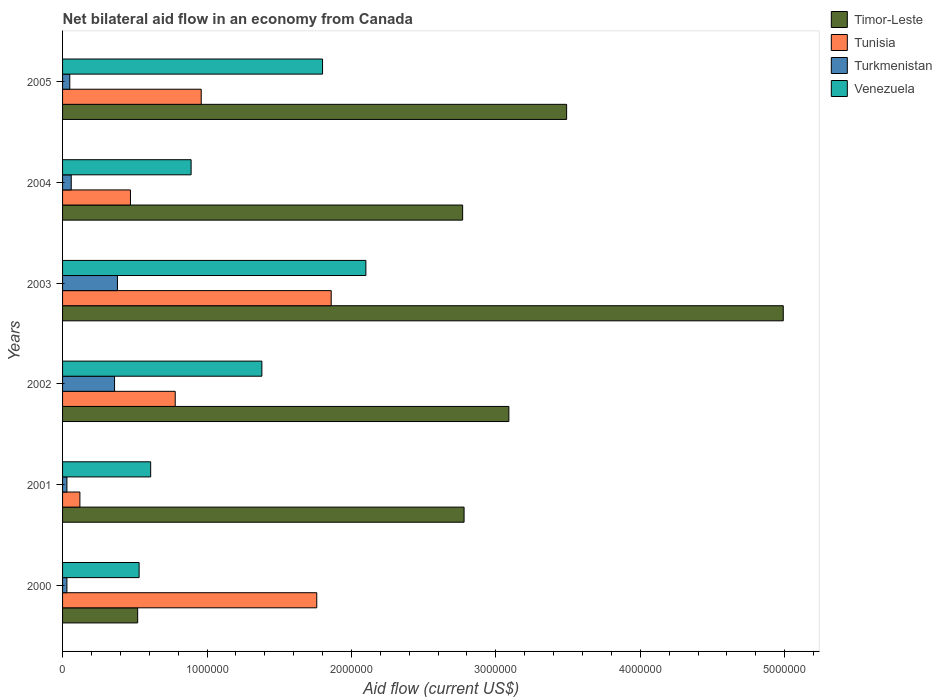How many groups of bars are there?
Give a very brief answer. 6. Are the number of bars per tick equal to the number of legend labels?
Your response must be concise. Yes. How many bars are there on the 5th tick from the top?
Offer a very short reply. 4. What is the label of the 4th group of bars from the top?
Offer a terse response. 2002. In how many cases, is the number of bars for a given year not equal to the number of legend labels?
Offer a very short reply. 0. What is the net bilateral aid flow in Venezuela in 2002?
Provide a succinct answer. 1.38e+06. In which year was the net bilateral aid flow in Tunisia minimum?
Make the answer very short. 2001. What is the total net bilateral aid flow in Venezuela in the graph?
Ensure brevity in your answer.  7.31e+06. What is the difference between the net bilateral aid flow in Venezuela in 2004 and that in 2005?
Your answer should be very brief. -9.10e+05. What is the difference between the net bilateral aid flow in Tunisia in 2000 and the net bilateral aid flow in Timor-Leste in 2001?
Your answer should be very brief. -1.02e+06. What is the average net bilateral aid flow in Timor-Leste per year?
Provide a succinct answer. 2.94e+06. In the year 2003, what is the difference between the net bilateral aid flow in Tunisia and net bilateral aid flow in Venezuela?
Make the answer very short. -2.40e+05. In how many years, is the net bilateral aid flow in Venezuela greater than 2000000 US$?
Provide a succinct answer. 1. What is the ratio of the net bilateral aid flow in Venezuela in 2001 to that in 2002?
Keep it short and to the point. 0.44. What is the difference between the highest and the second highest net bilateral aid flow in Turkmenistan?
Keep it short and to the point. 2.00e+04. What is the difference between the highest and the lowest net bilateral aid flow in Timor-Leste?
Offer a terse response. 4.47e+06. Is the sum of the net bilateral aid flow in Timor-Leste in 2002 and 2004 greater than the maximum net bilateral aid flow in Venezuela across all years?
Provide a succinct answer. Yes. What does the 3rd bar from the top in 2000 represents?
Ensure brevity in your answer.  Tunisia. What does the 1st bar from the bottom in 2002 represents?
Your answer should be very brief. Timor-Leste. Are all the bars in the graph horizontal?
Your response must be concise. Yes. How many years are there in the graph?
Provide a short and direct response. 6. Are the values on the major ticks of X-axis written in scientific E-notation?
Provide a short and direct response. No. Does the graph contain grids?
Offer a terse response. No. How many legend labels are there?
Ensure brevity in your answer.  4. How are the legend labels stacked?
Your response must be concise. Vertical. What is the title of the graph?
Provide a short and direct response. Net bilateral aid flow in an economy from Canada. Does "Middle East & North Africa (all income levels)" appear as one of the legend labels in the graph?
Ensure brevity in your answer.  No. What is the label or title of the X-axis?
Offer a very short reply. Aid flow (current US$). What is the Aid flow (current US$) of Timor-Leste in 2000?
Offer a very short reply. 5.20e+05. What is the Aid flow (current US$) in Tunisia in 2000?
Your answer should be very brief. 1.76e+06. What is the Aid flow (current US$) in Turkmenistan in 2000?
Keep it short and to the point. 3.00e+04. What is the Aid flow (current US$) of Venezuela in 2000?
Your response must be concise. 5.30e+05. What is the Aid flow (current US$) in Timor-Leste in 2001?
Offer a very short reply. 2.78e+06. What is the Aid flow (current US$) of Tunisia in 2001?
Keep it short and to the point. 1.20e+05. What is the Aid flow (current US$) of Timor-Leste in 2002?
Your answer should be compact. 3.09e+06. What is the Aid flow (current US$) of Tunisia in 2002?
Offer a terse response. 7.80e+05. What is the Aid flow (current US$) of Venezuela in 2002?
Make the answer very short. 1.38e+06. What is the Aid flow (current US$) of Timor-Leste in 2003?
Provide a succinct answer. 4.99e+06. What is the Aid flow (current US$) in Tunisia in 2003?
Provide a succinct answer. 1.86e+06. What is the Aid flow (current US$) of Turkmenistan in 2003?
Your answer should be very brief. 3.80e+05. What is the Aid flow (current US$) in Venezuela in 2003?
Offer a very short reply. 2.10e+06. What is the Aid flow (current US$) of Timor-Leste in 2004?
Offer a terse response. 2.77e+06. What is the Aid flow (current US$) in Venezuela in 2004?
Give a very brief answer. 8.90e+05. What is the Aid flow (current US$) of Timor-Leste in 2005?
Offer a very short reply. 3.49e+06. What is the Aid flow (current US$) in Tunisia in 2005?
Make the answer very short. 9.60e+05. What is the Aid flow (current US$) of Venezuela in 2005?
Your response must be concise. 1.80e+06. Across all years, what is the maximum Aid flow (current US$) in Timor-Leste?
Ensure brevity in your answer.  4.99e+06. Across all years, what is the maximum Aid flow (current US$) of Tunisia?
Provide a short and direct response. 1.86e+06. Across all years, what is the maximum Aid flow (current US$) of Turkmenistan?
Your response must be concise. 3.80e+05. Across all years, what is the maximum Aid flow (current US$) of Venezuela?
Your answer should be compact. 2.10e+06. Across all years, what is the minimum Aid flow (current US$) of Timor-Leste?
Your answer should be compact. 5.20e+05. Across all years, what is the minimum Aid flow (current US$) of Tunisia?
Make the answer very short. 1.20e+05. Across all years, what is the minimum Aid flow (current US$) in Turkmenistan?
Keep it short and to the point. 3.00e+04. Across all years, what is the minimum Aid flow (current US$) in Venezuela?
Your answer should be compact. 5.30e+05. What is the total Aid flow (current US$) of Timor-Leste in the graph?
Provide a succinct answer. 1.76e+07. What is the total Aid flow (current US$) of Tunisia in the graph?
Offer a very short reply. 5.95e+06. What is the total Aid flow (current US$) in Turkmenistan in the graph?
Provide a short and direct response. 9.10e+05. What is the total Aid flow (current US$) of Venezuela in the graph?
Keep it short and to the point. 7.31e+06. What is the difference between the Aid flow (current US$) in Timor-Leste in 2000 and that in 2001?
Provide a short and direct response. -2.26e+06. What is the difference between the Aid flow (current US$) in Tunisia in 2000 and that in 2001?
Provide a succinct answer. 1.64e+06. What is the difference between the Aid flow (current US$) of Turkmenistan in 2000 and that in 2001?
Keep it short and to the point. 0. What is the difference between the Aid flow (current US$) in Venezuela in 2000 and that in 2001?
Your answer should be compact. -8.00e+04. What is the difference between the Aid flow (current US$) of Timor-Leste in 2000 and that in 2002?
Offer a very short reply. -2.57e+06. What is the difference between the Aid flow (current US$) of Tunisia in 2000 and that in 2002?
Your response must be concise. 9.80e+05. What is the difference between the Aid flow (current US$) of Turkmenistan in 2000 and that in 2002?
Your answer should be very brief. -3.30e+05. What is the difference between the Aid flow (current US$) in Venezuela in 2000 and that in 2002?
Make the answer very short. -8.50e+05. What is the difference between the Aid flow (current US$) in Timor-Leste in 2000 and that in 2003?
Your answer should be very brief. -4.47e+06. What is the difference between the Aid flow (current US$) in Tunisia in 2000 and that in 2003?
Make the answer very short. -1.00e+05. What is the difference between the Aid flow (current US$) in Turkmenistan in 2000 and that in 2003?
Your answer should be compact. -3.50e+05. What is the difference between the Aid flow (current US$) of Venezuela in 2000 and that in 2003?
Make the answer very short. -1.57e+06. What is the difference between the Aid flow (current US$) of Timor-Leste in 2000 and that in 2004?
Give a very brief answer. -2.25e+06. What is the difference between the Aid flow (current US$) in Tunisia in 2000 and that in 2004?
Offer a very short reply. 1.29e+06. What is the difference between the Aid flow (current US$) in Turkmenistan in 2000 and that in 2004?
Your answer should be compact. -3.00e+04. What is the difference between the Aid flow (current US$) of Venezuela in 2000 and that in 2004?
Give a very brief answer. -3.60e+05. What is the difference between the Aid flow (current US$) in Timor-Leste in 2000 and that in 2005?
Ensure brevity in your answer.  -2.97e+06. What is the difference between the Aid flow (current US$) of Turkmenistan in 2000 and that in 2005?
Offer a terse response. -2.00e+04. What is the difference between the Aid flow (current US$) of Venezuela in 2000 and that in 2005?
Offer a very short reply. -1.27e+06. What is the difference between the Aid flow (current US$) of Timor-Leste in 2001 and that in 2002?
Provide a succinct answer. -3.10e+05. What is the difference between the Aid flow (current US$) in Tunisia in 2001 and that in 2002?
Give a very brief answer. -6.60e+05. What is the difference between the Aid flow (current US$) of Turkmenistan in 2001 and that in 2002?
Ensure brevity in your answer.  -3.30e+05. What is the difference between the Aid flow (current US$) in Venezuela in 2001 and that in 2002?
Ensure brevity in your answer.  -7.70e+05. What is the difference between the Aid flow (current US$) in Timor-Leste in 2001 and that in 2003?
Make the answer very short. -2.21e+06. What is the difference between the Aid flow (current US$) of Tunisia in 2001 and that in 2003?
Offer a very short reply. -1.74e+06. What is the difference between the Aid flow (current US$) of Turkmenistan in 2001 and that in 2003?
Your response must be concise. -3.50e+05. What is the difference between the Aid flow (current US$) in Venezuela in 2001 and that in 2003?
Offer a very short reply. -1.49e+06. What is the difference between the Aid flow (current US$) of Timor-Leste in 2001 and that in 2004?
Offer a terse response. 10000. What is the difference between the Aid flow (current US$) in Tunisia in 2001 and that in 2004?
Your answer should be compact. -3.50e+05. What is the difference between the Aid flow (current US$) of Turkmenistan in 2001 and that in 2004?
Make the answer very short. -3.00e+04. What is the difference between the Aid flow (current US$) of Venezuela in 2001 and that in 2004?
Ensure brevity in your answer.  -2.80e+05. What is the difference between the Aid flow (current US$) in Timor-Leste in 2001 and that in 2005?
Offer a very short reply. -7.10e+05. What is the difference between the Aid flow (current US$) of Tunisia in 2001 and that in 2005?
Ensure brevity in your answer.  -8.40e+05. What is the difference between the Aid flow (current US$) in Venezuela in 2001 and that in 2005?
Make the answer very short. -1.19e+06. What is the difference between the Aid flow (current US$) of Timor-Leste in 2002 and that in 2003?
Give a very brief answer. -1.90e+06. What is the difference between the Aid flow (current US$) in Tunisia in 2002 and that in 2003?
Your response must be concise. -1.08e+06. What is the difference between the Aid flow (current US$) in Turkmenistan in 2002 and that in 2003?
Provide a succinct answer. -2.00e+04. What is the difference between the Aid flow (current US$) in Venezuela in 2002 and that in 2003?
Make the answer very short. -7.20e+05. What is the difference between the Aid flow (current US$) of Tunisia in 2002 and that in 2004?
Provide a succinct answer. 3.10e+05. What is the difference between the Aid flow (current US$) of Venezuela in 2002 and that in 2004?
Give a very brief answer. 4.90e+05. What is the difference between the Aid flow (current US$) of Timor-Leste in 2002 and that in 2005?
Make the answer very short. -4.00e+05. What is the difference between the Aid flow (current US$) in Venezuela in 2002 and that in 2005?
Offer a terse response. -4.20e+05. What is the difference between the Aid flow (current US$) in Timor-Leste in 2003 and that in 2004?
Keep it short and to the point. 2.22e+06. What is the difference between the Aid flow (current US$) of Tunisia in 2003 and that in 2004?
Your answer should be very brief. 1.39e+06. What is the difference between the Aid flow (current US$) in Turkmenistan in 2003 and that in 2004?
Ensure brevity in your answer.  3.20e+05. What is the difference between the Aid flow (current US$) of Venezuela in 2003 and that in 2004?
Give a very brief answer. 1.21e+06. What is the difference between the Aid flow (current US$) in Timor-Leste in 2003 and that in 2005?
Your answer should be very brief. 1.50e+06. What is the difference between the Aid flow (current US$) of Venezuela in 2003 and that in 2005?
Make the answer very short. 3.00e+05. What is the difference between the Aid flow (current US$) of Timor-Leste in 2004 and that in 2005?
Offer a terse response. -7.20e+05. What is the difference between the Aid flow (current US$) in Tunisia in 2004 and that in 2005?
Your answer should be very brief. -4.90e+05. What is the difference between the Aid flow (current US$) in Turkmenistan in 2004 and that in 2005?
Make the answer very short. 10000. What is the difference between the Aid flow (current US$) of Venezuela in 2004 and that in 2005?
Your answer should be compact. -9.10e+05. What is the difference between the Aid flow (current US$) in Timor-Leste in 2000 and the Aid flow (current US$) in Turkmenistan in 2001?
Ensure brevity in your answer.  4.90e+05. What is the difference between the Aid flow (current US$) in Timor-Leste in 2000 and the Aid flow (current US$) in Venezuela in 2001?
Ensure brevity in your answer.  -9.00e+04. What is the difference between the Aid flow (current US$) in Tunisia in 2000 and the Aid flow (current US$) in Turkmenistan in 2001?
Offer a very short reply. 1.73e+06. What is the difference between the Aid flow (current US$) in Tunisia in 2000 and the Aid flow (current US$) in Venezuela in 2001?
Offer a terse response. 1.15e+06. What is the difference between the Aid flow (current US$) in Turkmenistan in 2000 and the Aid flow (current US$) in Venezuela in 2001?
Offer a terse response. -5.80e+05. What is the difference between the Aid flow (current US$) in Timor-Leste in 2000 and the Aid flow (current US$) in Venezuela in 2002?
Give a very brief answer. -8.60e+05. What is the difference between the Aid flow (current US$) of Tunisia in 2000 and the Aid flow (current US$) of Turkmenistan in 2002?
Provide a succinct answer. 1.40e+06. What is the difference between the Aid flow (current US$) in Turkmenistan in 2000 and the Aid flow (current US$) in Venezuela in 2002?
Your answer should be very brief. -1.35e+06. What is the difference between the Aid flow (current US$) of Timor-Leste in 2000 and the Aid flow (current US$) of Tunisia in 2003?
Your answer should be compact. -1.34e+06. What is the difference between the Aid flow (current US$) in Timor-Leste in 2000 and the Aid flow (current US$) in Venezuela in 2003?
Provide a short and direct response. -1.58e+06. What is the difference between the Aid flow (current US$) in Tunisia in 2000 and the Aid flow (current US$) in Turkmenistan in 2003?
Offer a very short reply. 1.38e+06. What is the difference between the Aid flow (current US$) of Tunisia in 2000 and the Aid flow (current US$) of Venezuela in 2003?
Offer a terse response. -3.40e+05. What is the difference between the Aid flow (current US$) of Turkmenistan in 2000 and the Aid flow (current US$) of Venezuela in 2003?
Offer a terse response. -2.07e+06. What is the difference between the Aid flow (current US$) in Timor-Leste in 2000 and the Aid flow (current US$) in Venezuela in 2004?
Provide a short and direct response. -3.70e+05. What is the difference between the Aid flow (current US$) in Tunisia in 2000 and the Aid flow (current US$) in Turkmenistan in 2004?
Make the answer very short. 1.70e+06. What is the difference between the Aid flow (current US$) in Tunisia in 2000 and the Aid flow (current US$) in Venezuela in 2004?
Give a very brief answer. 8.70e+05. What is the difference between the Aid flow (current US$) in Turkmenistan in 2000 and the Aid flow (current US$) in Venezuela in 2004?
Your answer should be compact. -8.60e+05. What is the difference between the Aid flow (current US$) in Timor-Leste in 2000 and the Aid flow (current US$) in Tunisia in 2005?
Make the answer very short. -4.40e+05. What is the difference between the Aid flow (current US$) in Timor-Leste in 2000 and the Aid flow (current US$) in Venezuela in 2005?
Offer a terse response. -1.28e+06. What is the difference between the Aid flow (current US$) in Tunisia in 2000 and the Aid flow (current US$) in Turkmenistan in 2005?
Make the answer very short. 1.71e+06. What is the difference between the Aid flow (current US$) of Turkmenistan in 2000 and the Aid flow (current US$) of Venezuela in 2005?
Ensure brevity in your answer.  -1.77e+06. What is the difference between the Aid flow (current US$) of Timor-Leste in 2001 and the Aid flow (current US$) of Turkmenistan in 2002?
Ensure brevity in your answer.  2.42e+06. What is the difference between the Aid flow (current US$) of Timor-Leste in 2001 and the Aid flow (current US$) of Venezuela in 2002?
Give a very brief answer. 1.40e+06. What is the difference between the Aid flow (current US$) in Tunisia in 2001 and the Aid flow (current US$) in Turkmenistan in 2002?
Provide a succinct answer. -2.40e+05. What is the difference between the Aid flow (current US$) of Tunisia in 2001 and the Aid flow (current US$) of Venezuela in 2002?
Provide a succinct answer. -1.26e+06. What is the difference between the Aid flow (current US$) of Turkmenistan in 2001 and the Aid flow (current US$) of Venezuela in 2002?
Keep it short and to the point. -1.35e+06. What is the difference between the Aid flow (current US$) of Timor-Leste in 2001 and the Aid flow (current US$) of Tunisia in 2003?
Offer a very short reply. 9.20e+05. What is the difference between the Aid flow (current US$) in Timor-Leste in 2001 and the Aid flow (current US$) in Turkmenistan in 2003?
Your answer should be very brief. 2.40e+06. What is the difference between the Aid flow (current US$) in Timor-Leste in 2001 and the Aid flow (current US$) in Venezuela in 2003?
Provide a succinct answer. 6.80e+05. What is the difference between the Aid flow (current US$) of Tunisia in 2001 and the Aid flow (current US$) of Turkmenistan in 2003?
Offer a very short reply. -2.60e+05. What is the difference between the Aid flow (current US$) of Tunisia in 2001 and the Aid flow (current US$) of Venezuela in 2003?
Ensure brevity in your answer.  -1.98e+06. What is the difference between the Aid flow (current US$) in Turkmenistan in 2001 and the Aid flow (current US$) in Venezuela in 2003?
Ensure brevity in your answer.  -2.07e+06. What is the difference between the Aid flow (current US$) in Timor-Leste in 2001 and the Aid flow (current US$) in Tunisia in 2004?
Your answer should be very brief. 2.31e+06. What is the difference between the Aid flow (current US$) in Timor-Leste in 2001 and the Aid flow (current US$) in Turkmenistan in 2004?
Give a very brief answer. 2.72e+06. What is the difference between the Aid flow (current US$) in Timor-Leste in 2001 and the Aid flow (current US$) in Venezuela in 2004?
Give a very brief answer. 1.89e+06. What is the difference between the Aid flow (current US$) of Tunisia in 2001 and the Aid flow (current US$) of Turkmenistan in 2004?
Keep it short and to the point. 6.00e+04. What is the difference between the Aid flow (current US$) of Tunisia in 2001 and the Aid flow (current US$) of Venezuela in 2004?
Your answer should be compact. -7.70e+05. What is the difference between the Aid flow (current US$) of Turkmenistan in 2001 and the Aid flow (current US$) of Venezuela in 2004?
Give a very brief answer. -8.60e+05. What is the difference between the Aid flow (current US$) in Timor-Leste in 2001 and the Aid flow (current US$) in Tunisia in 2005?
Provide a short and direct response. 1.82e+06. What is the difference between the Aid flow (current US$) in Timor-Leste in 2001 and the Aid flow (current US$) in Turkmenistan in 2005?
Ensure brevity in your answer.  2.73e+06. What is the difference between the Aid flow (current US$) in Timor-Leste in 2001 and the Aid flow (current US$) in Venezuela in 2005?
Your answer should be very brief. 9.80e+05. What is the difference between the Aid flow (current US$) in Tunisia in 2001 and the Aid flow (current US$) in Turkmenistan in 2005?
Your answer should be very brief. 7.00e+04. What is the difference between the Aid flow (current US$) in Tunisia in 2001 and the Aid flow (current US$) in Venezuela in 2005?
Offer a terse response. -1.68e+06. What is the difference between the Aid flow (current US$) in Turkmenistan in 2001 and the Aid flow (current US$) in Venezuela in 2005?
Your answer should be very brief. -1.77e+06. What is the difference between the Aid flow (current US$) in Timor-Leste in 2002 and the Aid flow (current US$) in Tunisia in 2003?
Give a very brief answer. 1.23e+06. What is the difference between the Aid flow (current US$) of Timor-Leste in 2002 and the Aid flow (current US$) of Turkmenistan in 2003?
Your answer should be very brief. 2.71e+06. What is the difference between the Aid flow (current US$) in Timor-Leste in 2002 and the Aid flow (current US$) in Venezuela in 2003?
Ensure brevity in your answer.  9.90e+05. What is the difference between the Aid flow (current US$) of Tunisia in 2002 and the Aid flow (current US$) of Turkmenistan in 2003?
Provide a short and direct response. 4.00e+05. What is the difference between the Aid flow (current US$) in Tunisia in 2002 and the Aid flow (current US$) in Venezuela in 2003?
Your response must be concise. -1.32e+06. What is the difference between the Aid flow (current US$) in Turkmenistan in 2002 and the Aid flow (current US$) in Venezuela in 2003?
Your answer should be very brief. -1.74e+06. What is the difference between the Aid flow (current US$) of Timor-Leste in 2002 and the Aid flow (current US$) of Tunisia in 2004?
Your response must be concise. 2.62e+06. What is the difference between the Aid flow (current US$) of Timor-Leste in 2002 and the Aid flow (current US$) of Turkmenistan in 2004?
Provide a short and direct response. 3.03e+06. What is the difference between the Aid flow (current US$) of Timor-Leste in 2002 and the Aid flow (current US$) of Venezuela in 2004?
Your answer should be very brief. 2.20e+06. What is the difference between the Aid flow (current US$) of Tunisia in 2002 and the Aid flow (current US$) of Turkmenistan in 2004?
Provide a succinct answer. 7.20e+05. What is the difference between the Aid flow (current US$) in Turkmenistan in 2002 and the Aid flow (current US$) in Venezuela in 2004?
Give a very brief answer. -5.30e+05. What is the difference between the Aid flow (current US$) of Timor-Leste in 2002 and the Aid flow (current US$) of Tunisia in 2005?
Offer a very short reply. 2.13e+06. What is the difference between the Aid flow (current US$) in Timor-Leste in 2002 and the Aid flow (current US$) in Turkmenistan in 2005?
Your response must be concise. 3.04e+06. What is the difference between the Aid flow (current US$) in Timor-Leste in 2002 and the Aid flow (current US$) in Venezuela in 2005?
Offer a very short reply. 1.29e+06. What is the difference between the Aid flow (current US$) in Tunisia in 2002 and the Aid flow (current US$) in Turkmenistan in 2005?
Your answer should be very brief. 7.30e+05. What is the difference between the Aid flow (current US$) of Tunisia in 2002 and the Aid flow (current US$) of Venezuela in 2005?
Your answer should be compact. -1.02e+06. What is the difference between the Aid flow (current US$) of Turkmenistan in 2002 and the Aid flow (current US$) of Venezuela in 2005?
Give a very brief answer. -1.44e+06. What is the difference between the Aid flow (current US$) of Timor-Leste in 2003 and the Aid flow (current US$) of Tunisia in 2004?
Ensure brevity in your answer.  4.52e+06. What is the difference between the Aid flow (current US$) in Timor-Leste in 2003 and the Aid flow (current US$) in Turkmenistan in 2004?
Your answer should be compact. 4.93e+06. What is the difference between the Aid flow (current US$) of Timor-Leste in 2003 and the Aid flow (current US$) of Venezuela in 2004?
Offer a very short reply. 4.10e+06. What is the difference between the Aid flow (current US$) of Tunisia in 2003 and the Aid flow (current US$) of Turkmenistan in 2004?
Your response must be concise. 1.80e+06. What is the difference between the Aid flow (current US$) in Tunisia in 2003 and the Aid flow (current US$) in Venezuela in 2004?
Your answer should be very brief. 9.70e+05. What is the difference between the Aid flow (current US$) in Turkmenistan in 2003 and the Aid flow (current US$) in Venezuela in 2004?
Provide a succinct answer. -5.10e+05. What is the difference between the Aid flow (current US$) in Timor-Leste in 2003 and the Aid flow (current US$) in Tunisia in 2005?
Provide a succinct answer. 4.03e+06. What is the difference between the Aid flow (current US$) in Timor-Leste in 2003 and the Aid flow (current US$) in Turkmenistan in 2005?
Offer a very short reply. 4.94e+06. What is the difference between the Aid flow (current US$) of Timor-Leste in 2003 and the Aid flow (current US$) of Venezuela in 2005?
Your answer should be very brief. 3.19e+06. What is the difference between the Aid flow (current US$) in Tunisia in 2003 and the Aid flow (current US$) in Turkmenistan in 2005?
Make the answer very short. 1.81e+06. What is the difference between the Aid flow (current US$) of Tunisia in 2003 and the Aid flow (current US$) of Venezuela in 2005?
Give a very brief answer. 6.00e+04. What is the difference between the Aid flow (current US$) in Turkmenistan in 2003 and the Aid flow (current US$) in Venezuela in 2005?
Ensure brevity in your answer.  -1.42e+06. What is the difference between the Aid flow (current US$) of Timor-Leste in 2004 and the Aid flow (current US$) of Tunisia in 2005?
Offer a terse response. 1.81e+06. What is the difference between the Aid flow (current US$) in Timor-Leste in 2004 and the Aid flow (current US$) in Turkmenistan in 2005?
Keep it short and to the point. 2.72e+06. What is the difference between the Aid flow (current US$) of Timor-Leste in 2004 and the Aid flow (current US$) of Venezuela in 2005?
Offer a terse response. 9.70e+05. What is the difference between the Aid flow (current US$) in Tunisia in 2004 and the Aid flow (current US$) in Turkmenistan in 2005?
Your answer should be compact. 4.20e+05. What is the difference between the Aid flow (current US$) in Tunisia in 2004 and the Aid flow (current US$) in Venezuela in 2005?
Offer a terse response. -1.33e+06. What is the difference between the Aid flow (current US$) of Turkmenistan in 2004 and the Aid flow (current US$) of Venezuela in 2005?
Provide a short and direct response. -1.74e+06. What is the average Aid flow (current US$) in Timor-Leste per year?
Your response must be concise. 2.94e+06. What is the average Aid flow (current US$) of Tunisia per year?
Your answer should be compact. 9.92e+05. What is the average Aid flow (current US$) in Turkmenistan per year?
Ensure brevity in your answer.  1.52e+05. What is the average Aid flow (current US$) of Venezuela per year?
Your answer should be very brief. 1.22e+06. In the year 2000, what is the difference between the Aid flow (current US$) of Timor-Leste and Aid flow (current US$) of Tunisia?
Ensure brevity in your answer.  -1.24e+06. In the year 2000, what is the difference between the Aid flow (current US$) in Tunisia and Aid flow (current US$) in Turkmenistan?
Your answer should be compact. 1.73e+06. In the year 2000, what is the difference between the Aid flow (current US$) in Tunisia and Aid flow (current US$) in Venezuela?
Provide a succinct answer. 1.23e+06. In the year 2000, what is the difference between the Aid flow (current US$) of Turkmenistan and Aid flow (current US$) of Venezuela?
Your answer should be very brief. -5.00e+05. In the year 2001, what is the difference between the Aid flow (current US$) in Timor-Leste and Aid flow (current US$) in Tunisia?
Offer a very short reply. 2.66e+06. In the year 2001, what is the difference between the Aid flow (current US$) of Timor-Leste and Aid flow (current US$) of Turkmenistan?
Ensure brevity in your answer.  2.75e+06. In the year 2001, what is the difference between the Aid flow (current US$) in Timor-Leste and Aid flow (current US$) in Venezuela?
Your response must be concise. 2.17e+06. In the year 2001, what is the difference between the Aid flow (current US$) in Tunisia and Aid flow (current US$) in Venezuela?
Provide a succinct answer. -4.90e+05. In the year 2001, what is the difference between the Aid flow (current US$) in Turkmenistan and Aid flow (current US$) in Venezuela?
Give a very brief answer. -5.80e+05. In the year 2002, what is the difference between the Aid flow (current US$) of Timor-Leste and Aid flow (current US$) of Tunisia?
Your answer should be very brief. 2.31e+06. In the year 2002, what is the difference between the Aid flow (current US$) in Timor-Leste and Aid flow (current US$) in Turkmenistan?
Offer a terse response. 2.73e+06. In the year 2002, what is the difference between the Aid flow (current US$) of Timor-Leste and Aid flow (current US$) of Venezuela?
Offer a terse response. 1.71e+06. In the year 2002, what is the difference between the Aid flow (current US$) of Tunisia and Aid flow (current US$) of Venezuela?
Provide a succinct answer. -6.00e+05. In the year 2002, what is the difference between the Aid flow (current US$) of Turkmenistan and Aid flow (current US$) of Venezuela?
Provide a short and direct response. -1.02e+06. In the year 2003, what is the difference between the Aid flow (current US$) in Timor-Leste and Aid flow (current US$) in Tunisia?
Offer a very short reply. 3.13e+06. In the year 2003, what is the difference between the Aid flow (current US$) in Timor-Leste and Aid flow (current US$) in Turkmenistan?
Offer a terse response. 4.61e+06. In the year 2003, what is the difference between the Aid flow (current US$) in Timor-Leste and Aid flow (current US$) in Venezuela?
Ensure brevity in your answer.  2.89e+06. In the year 2003, what is the difference between the Aid flow (current US$) of Tunisia and Aid flow (current US$) of Turkmenistan?
Provide a succinct answer. 1.48e+06. In the year 2003, what is the difference between the Aid flow (current US$) of Tunisia and Aid flow (current US$) of Venezuela?
Keep it short and to the point. -2.40e+05. In the year 2003, what is the difference between the Aid flow (current US$) in Turkmenistan and Aid flow (current US$) in Venezuela?
Your answer should be very brief. -1.72e+06. In the year 2004, what is the difference between the Aid flow (current US$) in Timor-Leste and Aid flow (current US$) in Tunisia?
Ensure brevity in your answer.  2.30e+06. In the year 2004, what is the difference between the Aid flow (current US$) of Timor-Leste and Aid flow (current US$) of Turkmenistan?
Your answer should be compact. 2.71e+06. In the year 2004, what is the difference between the Aid flow (current US$) in Timor-Leste and Aid flow (current US$) in Venezuela?
Offer a very short reply. 1.88e+06. In the year 2004, what is the difference between the Aid flow (current US$) of Tunisia and Aid flow (current US$) of Venezuela?
Give a very brief answer. -4.20e+05. In the year 2004, what is the difference between the Aid flow (current US$) of Turkmenistan and Aid flow (current US$) of Venezuela?
Give a very brief answer. -8.30e+05. In the year 2005, what is the difference between the Aid flow (current US$) in Timor-Leste and Aid flow (current US$) in Tunisia?
Keep it short and to the point. 2.53e+06. In the year 2005, what is the difference between the Aid flow (current US$) of Timor-Leste and Aid flow (current US$) of Turkmenistan?
Make the answer very short. 3.44e+06. In the year 2005, what is the difference between the Aid flow (current US$) of Timor-Leste and Aid flow (current US$) of Venezuela?
Offer a very short reply. 1.69e+06. In the year 2005, what is the difference between the Aid flow (current US$) of Tunisia and Aid flow (current US$) of Turkmenistan?
Your response must be concise. 9.10e+05. In the year 2005, what is the difference between the Aid flow (current US$) of Tunisia and Aid flow (current US$) of Venezuela?
Offer a terse response. -8.40e+05. In the year 2005, what is the difference between the Aid flow (current US$) of Turkmenistan and Aid flow (current US$) of Venezuela?
Keep it short and to the point. -1.75e+06. What is the ratio of the Aid flow (current US$) in Timor-Leste in 2000 to that in 2001?
Offer a terse response. 0.19. What is the ratio of the Aid flow (current US$) of Tunisia in 2000 to that in 2001?
Keep it short and to the point. 14.67. What is the ratio of the Aid flow (current US$) of Turkmenistan in 2000 to that in 2001?
Keep it short and to the point. 1. What is the ratio of the Aid flow (current US$) in Venezuela in 2000 to that in 2001?
Offer a terse response. 0.87. What is the ratio of the Aid flow (current US$) in Timor-Leste in 2000 to that in 2002?
Make the answer very short. 0.17. What is the ratio of the Aid flow (current US$) of Tunisia in 2000 to that in 2002?
Give a very brief answer. 2.26. What is the ratio of the Aid flow (current US$) in Turkmenistan in 2000 to that in 2002?
Provide a succinct answer. 0.08. What is the ratio of the Aid flow (current US$) in Venezuela in 2000 to that in 2002?
Make the answer very short. 0.38. What is the ratio of the Aid flow (current US$) in Timor-Leste in 2000 to that in 2003?
Provide a short and direct response. 0.1. What is the ratio of the Aid flow (current US$) of Tunisia in 2000 to that in 2003?
Make the answer very short. 0.95. What is the ratio of the Aid flow (current US$) of Turkmenistan in 2000 to that in 2003?
Keep it short and to the point. 0.08. What is the ratio of the Aid flow (current US$) of Venezuela in 2000 to that in 2003?
Provide a succinct answer. 0.25. What is the ratio of the Aid flow (current US$) of Timor-Leste in 2000 to that in 2004?
Provide a succinct answer. 0.19. What is the ratio of the Aid flow (current US$) of Tunisia in 2000 to that in 2004?
Keep it short and to the point. 3.74. What is the ratio of the Aid flow (current US$) of Turkmenistan in 2000 to that in 2004?
Ensure brevity in your answer.  0.5. What is the ratio of the Aid flow (current US$) of Venezuela in 2000 to that in 2004?
Your answer should be very brief. 0.6. What is the ratio of the Aid flow (current US$) in Timor-Leste in 2000 to that in 2005?
Offer a very short reply. 0.15. What is the ratio of the Aid flow (current US$) in Tunisia in 2000 to that in 2005?
Your response must be concise. 1.83. What is the ratio of the Aid flow (current US$) in Turkmenistan in 2000 to that in 2005?
Ensure brevity in your answer.  0.6. What is the ratio of the Aid flow (current US$) in Venezuela in 2000 to that in 2005?
Ensure brevity in your answer.  0.29. What is the ratio of the Aid flow (current US$) in Timor-Leste in 2001 to that in 2002?
Provide a short and direct response. 0.9. What is the ratio of the Aid flow (current US$) in Tunisia in 2001 to that in 2002?
Offer a terse response. 0.15. What is the ratio of the Aid flow (current US$) in Turkmenistan in 2001 to that in 2002?
Provide a short and direct response. 0.08. What is the ratio of the Aid flow (current US$) of Venezuela in 2001 to that in 2002?
Your answer should be very brief. 0.44. What is the ratio of the Aid flow (current US$) in Timor-Leste in 2001 to that in 2003?
Your response must be concise. 0.56. What is the ratio of the Aid flow (current US$) in Tunisia in 2001 to that in 2003?
Provide a succinct answer. 0.06. What is the ratio of the Aid flow (current US$) in Turkmenistan in 2001 to that in 2003?
Your response must be concise. 0.08. What is the ratio of the Aid flow (current US$) of Venezuela in 2001 to that in 2003?
Your answer should be very brief. 0.29. What is the ratio of the Aid flow (current US$) of Tunisia in 2001 to that in 2004?
Your answer should be compact. 0.26. What is the ratio of the Aid flow (current US$) in Venezuela in 2001 to that in 2004?
Keep it short and to the point. 0.69. What is the ratio of the Aid flow (current US$) in Timor-Leste in 2001 to that in 2005?
Give a very brief answer. 0.8. What is the ratio of the Aid flow (current US$) of Tunisia in 2001 to that in 2005?
Give a very brief answer. 0.12. What is the ratio of the Aid flow (current US$) of Turkmenistan in 2001 to that in 2005?
Ensure brevity in your answer.  0.6. What is the ratio of the Aid flow (current US$) in Venezuela in 2001 to that in 2005?
Give a very brief answer. 0.34. What is the ratio of the Aid flow (current US$) of Timor-Leste in 2002 to that in 2003?
Give a very brief answer. 0.62. What is the ratio of the Aid flow (current US$) in Tunisia in 2002 to that in 2003?
Ensure brevity in your answer.  0.42. What is the ratio of the Aid flow (current US$) in Turkmenistan in 2002 to that in 2003?
Your answer should be compact. 0.95. What is the ratio of the Aid flow (current US$) in Venezuela in 2002 to that in 2003?
Make the answer very short. 0.66. What is the ratio of the Aid flow (current US$) of Timor-Leste in 2002 to that in 2004?
Give a very brief answer. 1.12. What is the ratio of the Aid flow (current US$) in Tunisia in 2002 to that in 2004?
Make the answer very short. 1.66. What is the ratio of the Aid flow (current US$) in Turkmenistan in 2002 to that in 2004?
Offer a terse response. 6. What is the ratio of the Aid flow (current US$) of Venezuela in 2002 to that in 2004?
Your answer should be compact. 1.55. What is the ratio of the Aid flow (current US$) of Timor-Leste in 2002 to that in 2005?
Provide a succinct answer. 0.89. What is the ratio of the Aid flow (current US$) in Tunisia in 2002 to that in 2005?
Provide a succinct answer. 0.81. What is the ratio of the Aid flow (current US$) of Venezuela in 2002 to that in 2005?
Give a very brief answer. 0.77. What is the ratio of the Aid flow (current US$) of Timor-Leste in 2003 to that in 2004?
Make the answer very short. 1.8. What is the ratio of the Aid flow (current US$) of Tunisia in 2003 to that in 2004?
Give a very brief answer. 3.96. What is the ratio of the Aid flow (current US$) of Turkmenistan in 2003 to that in 2004?
Keep it short and to the point. 6.33. What is the ratio of the Aid flow (current US$) of Venezuela in 2003 to that in 2004?
Provide a succinct answer. 2.36. What is the ratio of the Aid flow (current US$) in Timor-Leste in 2003 to that in 2005?
Keep it short and to the point. 1.43. What is the ratio of the Aid flow (current US$) in Tunisia in 2003 to that in 2005?
Provide a succinct answer. 1.94. What is the ratio of the Aid flow (current US$) in Turkmenistan in 2003 to that in 2005?
Ensure brevity in your answer.  7.6. What is the ratio of the Aid flow (current US$) of Venezuela in 2003 to that in 2005?
Offer a terse response. 1.17. What is the ratio of the Aid flow (current US$) of Timor-Leste in 2004 to that in 2005?
Make the answer very short. 0.79. What is the ratio of the Aid flow (current US$) of Tunisia in 2004 to that in 2005?
Your answer should be very brief. 0.49. What is the ratio of the Aid flow (current US$) of Turkmenistan in 2004 to that in 2005?
Your answer should be compact. 1.2. What is the ratio of the Aid flow (current US$) of Venezuela in 2004 to that in 2005?
Offer a very short reply. 0.49. What is the difference between the highest and the second highest Aid flow (current US$) in Timor-Leste?
Give a very brief answer. 1.50e+06. What is the difference between the highest and the second highest Aid flow (current US$) of Tunisia?
Keep it short and to the point. 1.00e+05. What is the difference between the highest and the lowest Aid flow (current US$) in Timor-Leste?
Keep it short and to the point. 4.47e+06. What is the difference between the highest and the lowest Aid flow (current US$) of Tunisia?
Your response must be concise. 1.74e+06. What is the difference between the highest and the lowest Aid flow (current US$) in Turkmenistan?
Give a very brief answer. 3.50e+05. What is the difference between the highest and the lowest Aid flow (current US$) of Venezuela?
Give a very brief answer. 1.57e+06. 